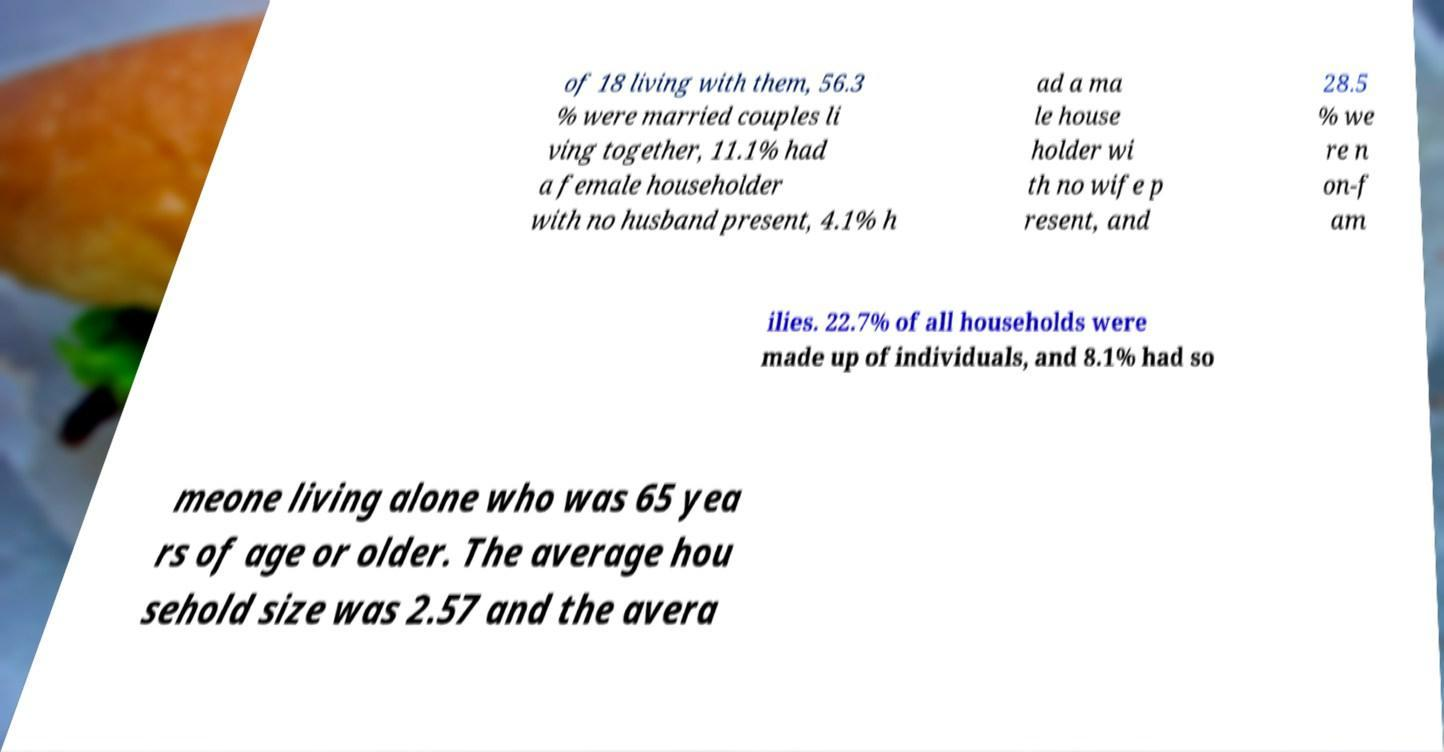Can you read and provide the text displayed in the image?This photo seems to have some interesting text. Can you extract and type it out for me? of 18 living with them, 56.3 % were married couples li ving together, 11.1% had a female householder with no husband present, 4.1% h ad a ma le house holder wi th no wife p resent, and 28.5 % we re n on-f am ilies. 22.7% of all households were made up of individuals, and 8.1% had so meone living alone who was 65 yea rs of age or older. The average hou sehold size was 2.57 and the avera 